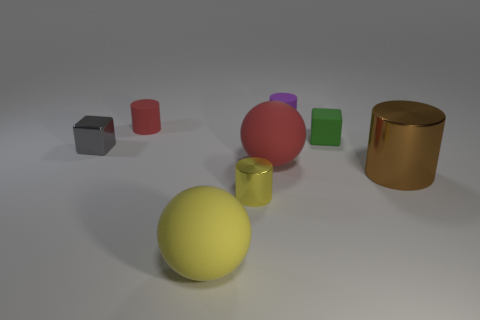Add 2 gray shiny cubes. How many objects exist? 10 Subtract all spheres. How many objects are left? 6 Add 6 big yellow things. How many big yellow things exist? 7 Subtract 0 gray cylinders. How many objects are left? 8 Subtract all metal cubes. Subtract all tiny blocks. How many objects are left? 5 Add 2 gray blocks. How many gray blocks are left? 3 